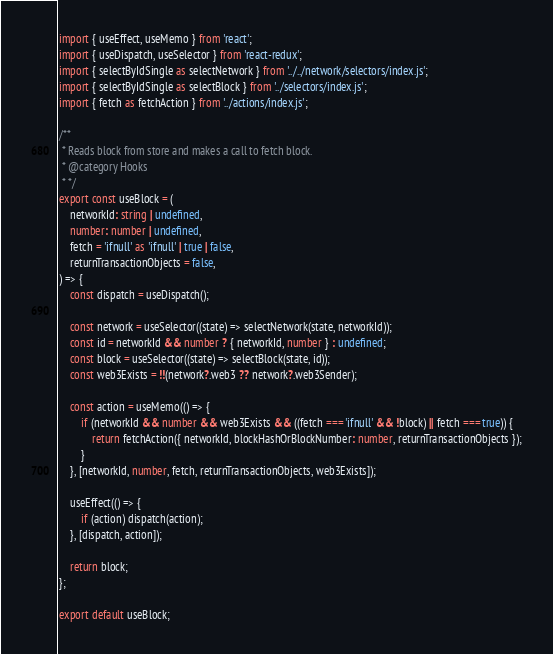<code> <loc_0><loc_0><loc_500><loc_500><_TypeScript_>import { useEffect, useMemo } from 'react';
import { useDispatch, useSelector } from 'react-redux';
import { selectByIdSingle as selectNetwork } from '../../network/selectors/index.js';
import { selectByIdSingle as selectBlock } from '../selectors/index.js';
import { fetch as fetchAction } from '../actions/index.js';

/**
 * Reads block from store and makes a call to fetch block.
 * @category Hooks
 * */
export const useBlock = (
    networkId: string | undefined,
    number: number | undefined,
    fetch = 'ifnull' as 'ifnull' | true | false,
    returnTransactionObjects = false,
) => {
    const dispatch = useDispatch();

    const network = useSelector((state) => selectNetwork(state, networkId));
    const id = networkId && number ? { networkId, number } : undefined;
    const block = useSelector((state) => selectBlock(state, id));
    const web3Exists = !!(network?.web3 ?? network?.web3Sender);

    const action = useMemo(() => {
        if (networkId && number && web3Exists && ((fetch === 'ifnull' && !block) || fetch === true)) {
            return fetchAction({ networkId, blockHashOrBlockNumber: number, returnTransactionObjects });
        }
    }, [networkId, number, fetch, returnTransactionObjects, web3Exists]);

    useEffect(() => {
        if (action) dispatch(action);
    }, [dispatch, action]);

    return block;
};

export default useBlock;
</code> 